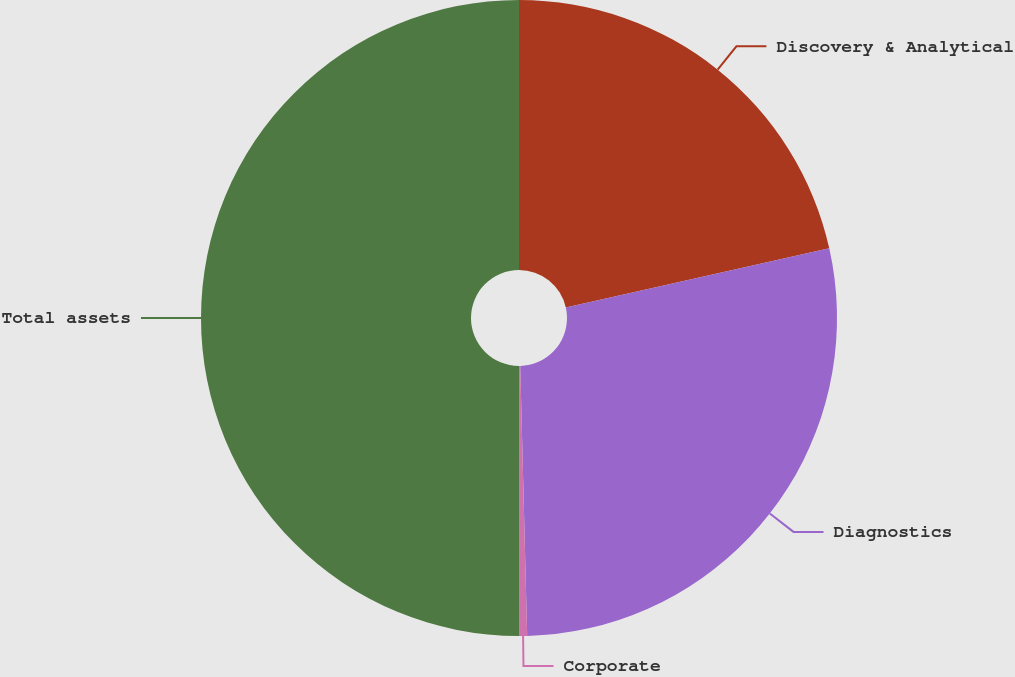Convert chart to OTSL. <chart><loc_0><loc_0><loc_500><loc_500><pie_chart><fcel>Discovery & Analytical<fcel>Diagnostics<fcel>Corporate<fcel>Total assets<nl><fcel>21.48%<fcel>28.11%<fcel>0.41%<fcel>50.0%<nl></chart> 